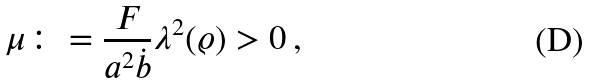Convert formula to latex. <formula><loc_0><loc_0><loc_500><loc_500>\mu \colon = \frac { F } { a ^ { 2 } { \dot { b } } } \lambda ^ { 2 } ( \varrho ) > 0 \, ,</formula> 